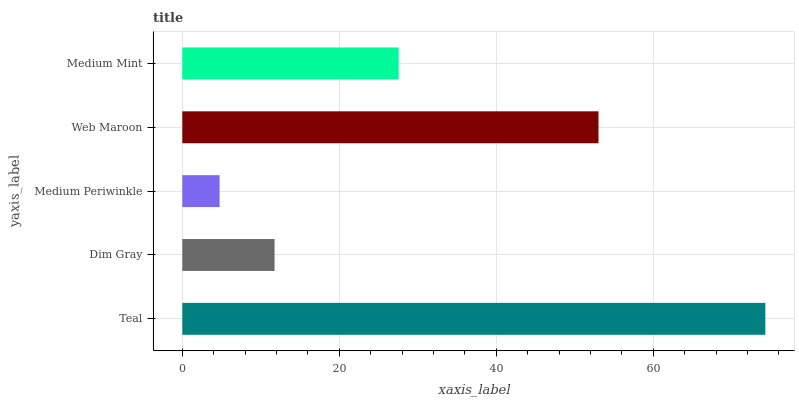Is Medium Periwinkle the minimum?
Answer yes or no. Yes. Is Teal the maximum?
Answer yes or no. Yes. Is Dim Gray the minimum?
Answer yes or no. No. Is Dim Gray the maximum?
Answer yes or no. No. Is Teal greater than Dim Gray?
Answer yes or no. Yes. Is Dim Gray less than Teal?
Answer yes or no. Yes. Is Dim Gray greater than Teal?
Answer yes or no. No. Is Teal less than Dim Gray?
Answer yes or no. No. Is Medium Mint the high median?
Answer yes or no. Yes. Is Medium Mint the low median?
Answer yes or no. Yes. Is Teal the high median?
Answer yes or no. No. Is Web Maroon the low median?
Answer yes or no. No. 